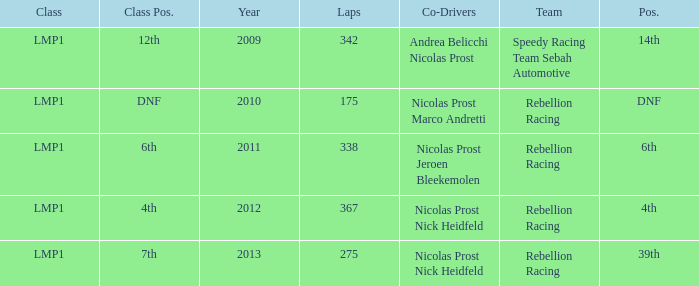What was the class position of the team that was in the 4th position? 4th. 